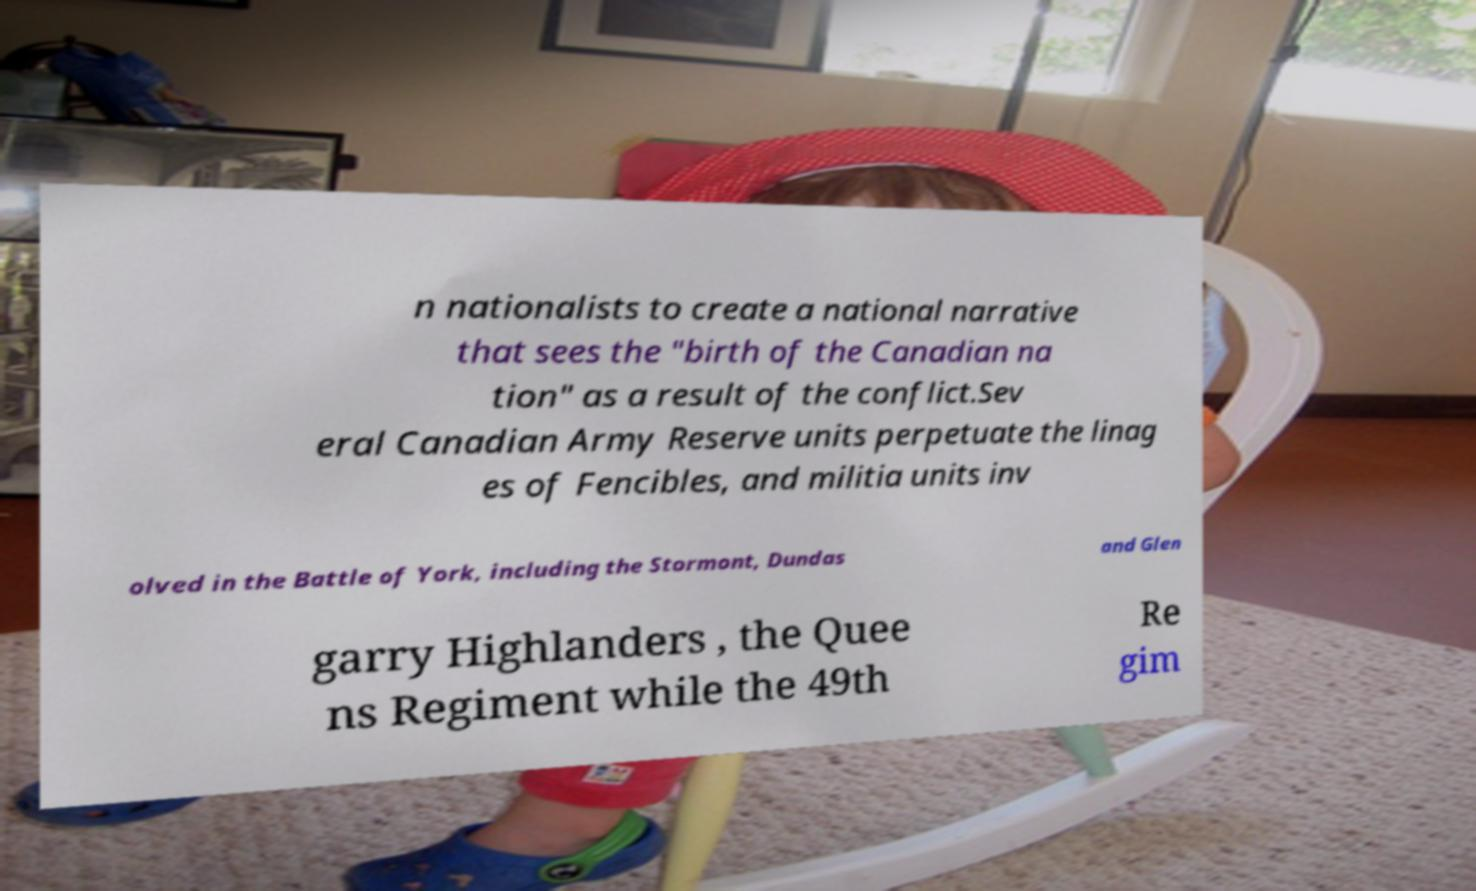Please read and relay the text visible in this image. What does it say? n nationalists to create a national narrative that sees the "birth of the Canadian na tion" as a result of the conflict.Sev eral Canadian Army Reserve units perpetuate the linag es of Fencibles, and militia units inv olved in the Battle of York, including the Stormont, Dundas and Glen garry Highlanders , the Quee ns Regiment while the 49th Re gim 